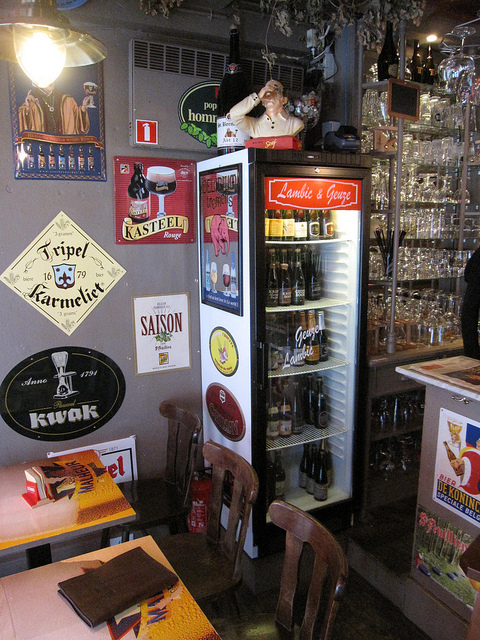How many chairs are there? 3 